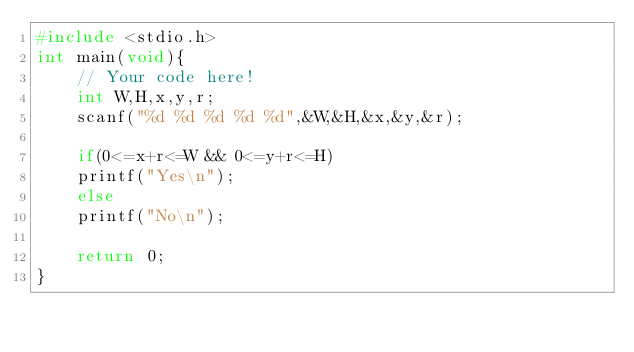<code> <loc_0><loc_0><loc_500><loc_500><_C_>#include <stdio.h>
int main(void){
    // Your code here!
    int W,H,x,y,r;
    scanf("%d %d %d %d %d",&W,&H,&x,&y,&r);
    
    if(0<=x+r<=W && 0<=y+r<=H)
    printf("Yes\n");
    else
    printf("No\n");
    
    return 0;
}

</code> 